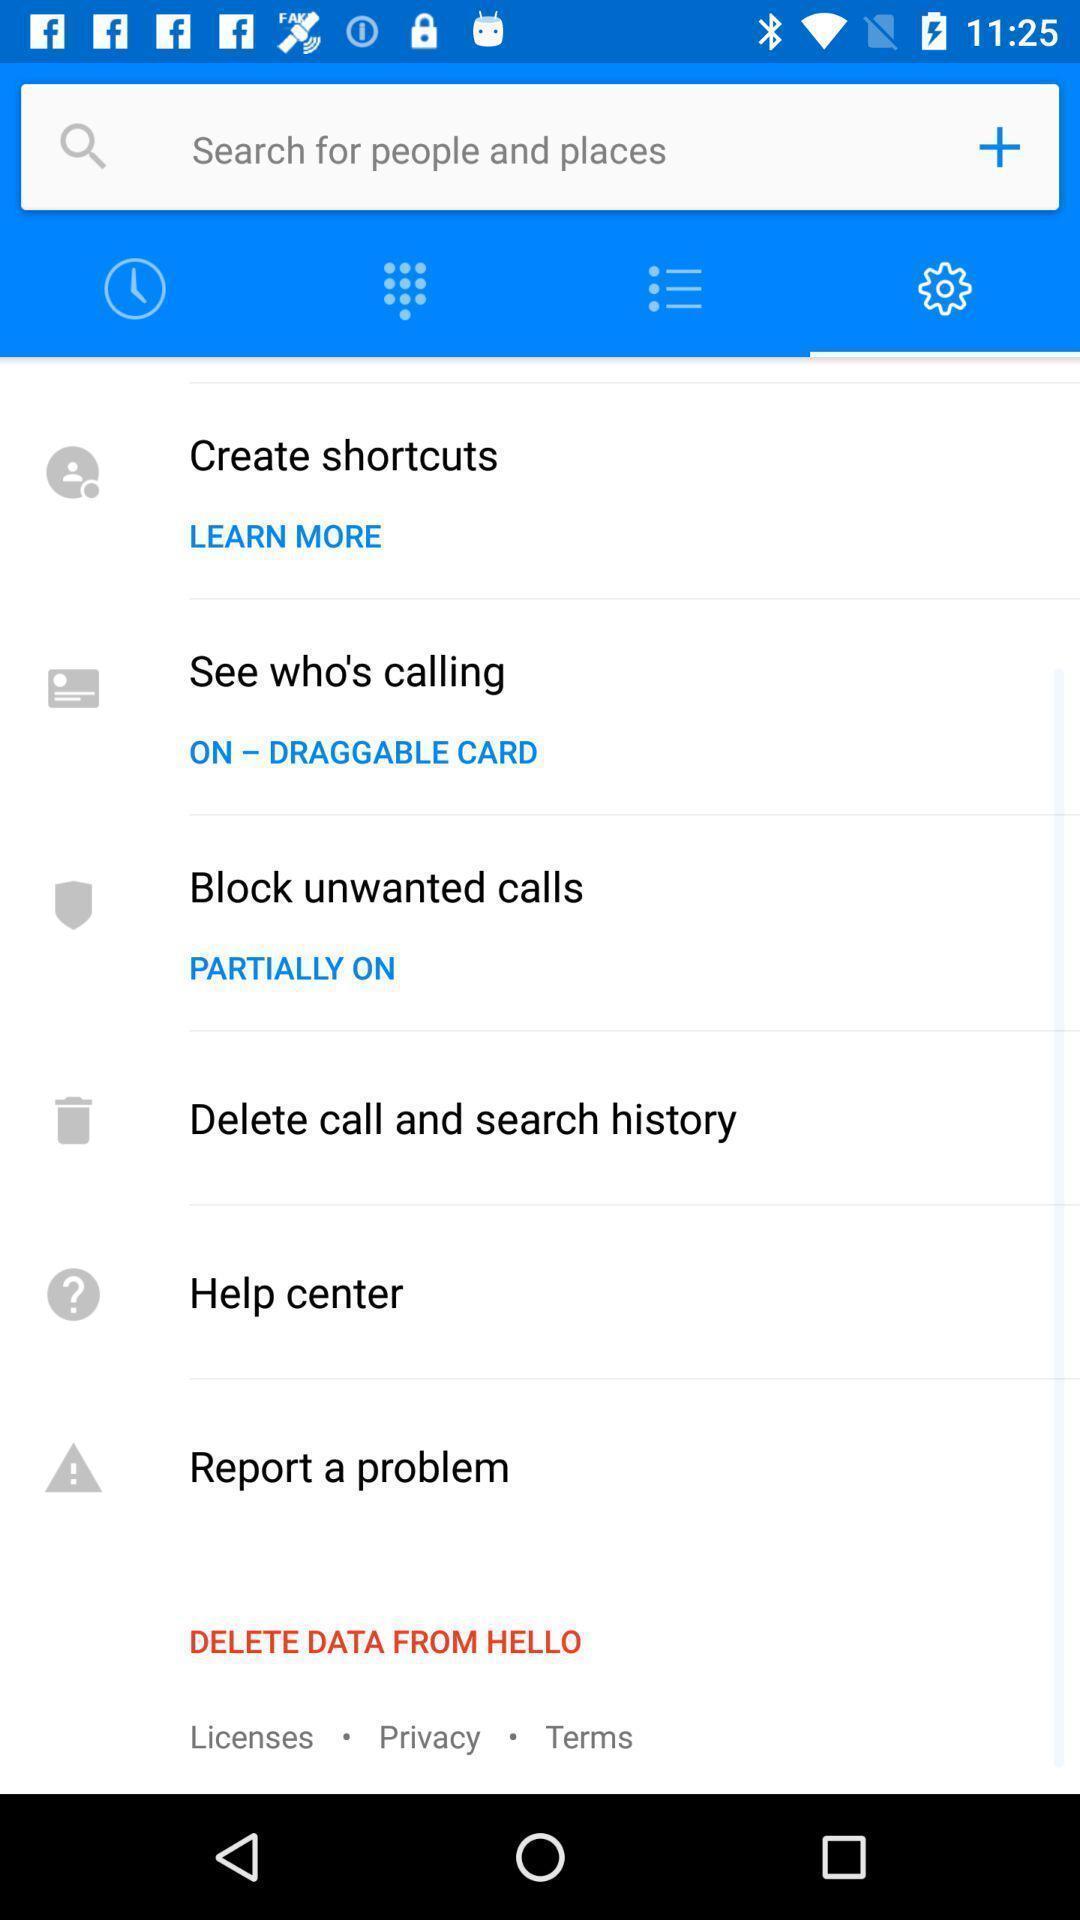Provide a textual representation of this image. Settings page of a calling app. 